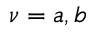Convert formula to latex. <formula><loc_0><loc_0><loc_500><loc_500>\nu = a , b</formula> 